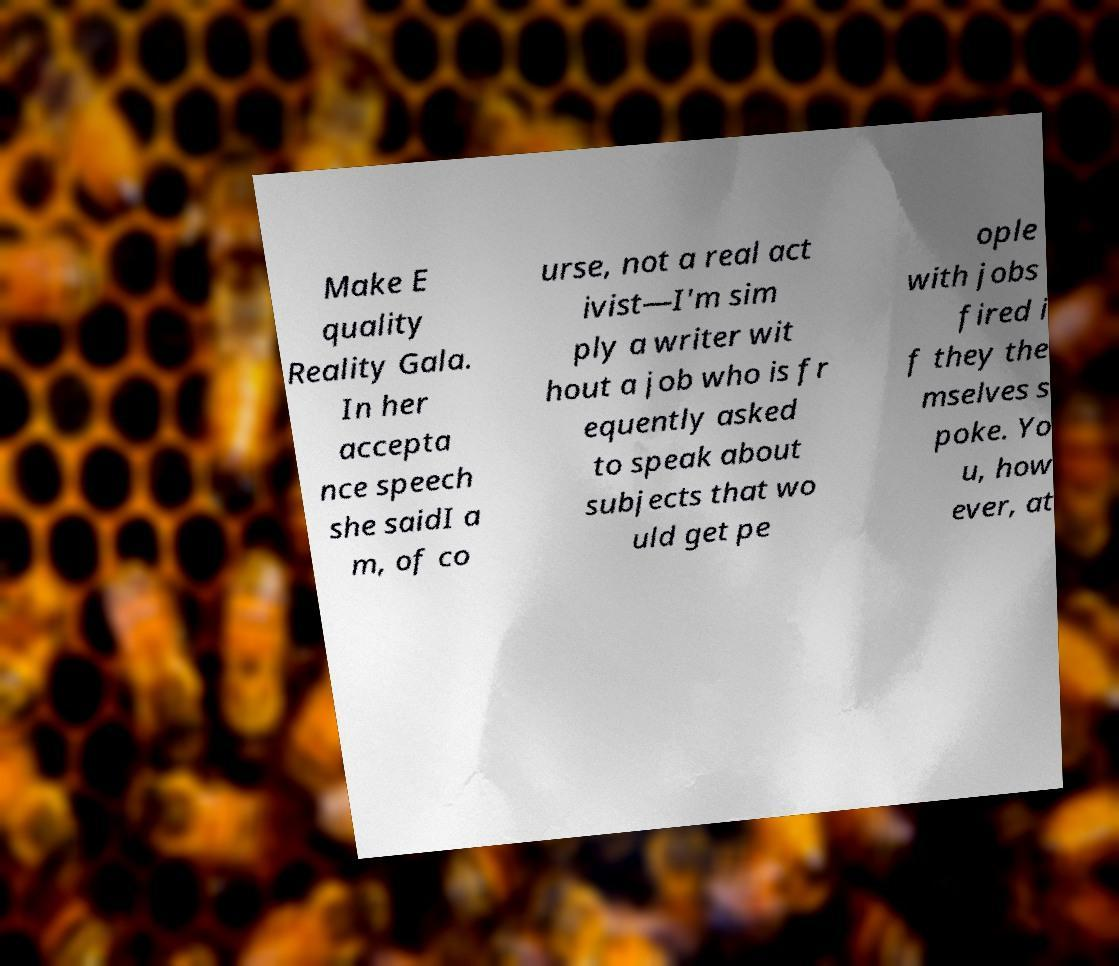There's text embedded in this image that I need extracted. Can you transcribe it verbatim? Make E quality Reality Gala. In her accepta nce speech she saidI a m, of co urse, not a real act ivist—I'm sim ply a writer wit hout a job who is fr equently asked to speak about subjects that wo uld get pe ople with jobs fired i f they the mselves s poke. Yo u, how ever, at 